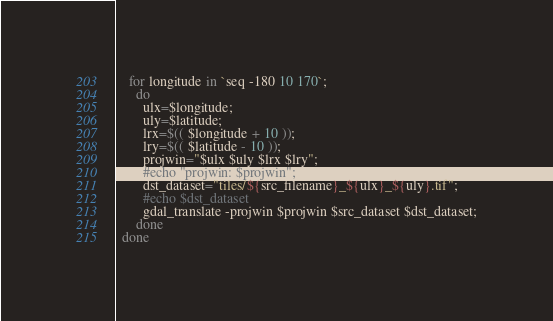<code> <loc_0><loc_0><loc_500><loc_500><_Bash_>    for longitude in `seq -180 10 170`;
      do
        ulx=$longitude;
        uly=$latitude;
        lrx=$(( $longitude + 10 ));
        lry=$(( $latitude - 10 ));
        projwin="$ulx $uly $lrx $lry";
        #echo "projwin: $projwin";
        dst_dataset="tiles/${src_filename}_${ulx}_${uly}.tif";
        #echo $dst_dataset
        gdal_translate -projwin $projwin $src_dataset $dst_dataset;
      done
  done   
</code> 